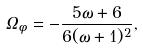<formula> <loc_0><loc_0><loc_500><loc_500>\Omega _ { \phi } = - \frac { 5 \omega + 6 } { 6 ( \omega + 1 ) ^ { 2 } } ,</formula> 